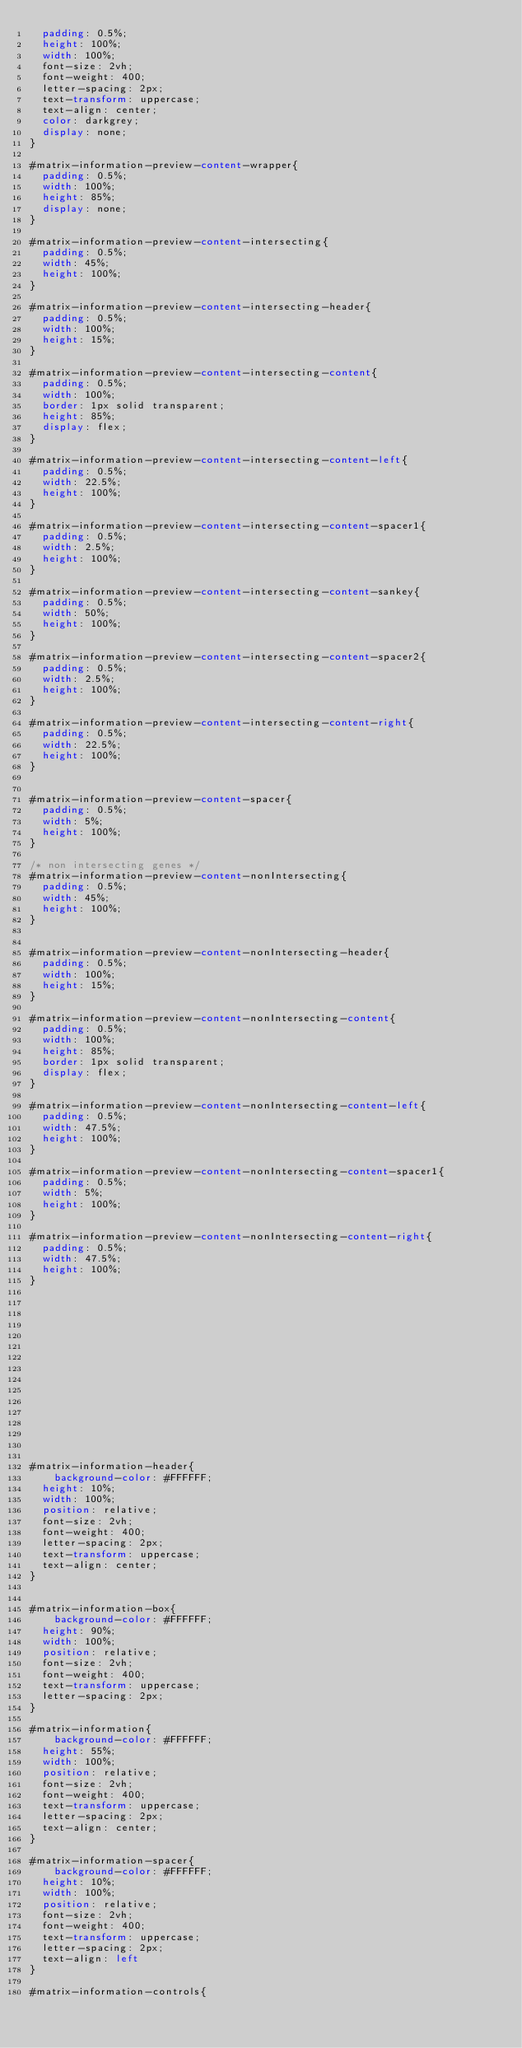<code> <loc_0><loc_0><loc_500><loc_500><_CSS_>	padding: 0.5%;
	height: 100%;
	width: 100%;
	font-size: 2vh;
	font-weight: 400;
	letter-spacing: 2px;
	text-transform: uppercase;
	text-align: center;
	color: darkgrey;
	display: none;
}

#matrix-information-preview-content-wrapper{
	padding: 0.5%;
	width: 100%;
	height: 85%;
	display: none;
}

#matrix-information-preview-content-intersecting{
	padding: 0.5%;
	width: 45%;
	height: 100%;
}

#matrix-information-preview-content-intersecting-header{
	padding: 0.5%;
	width: 100%;
	height: 15%;
}

#matrix-information-preview-content-intersecting-content{
	padding: 0.5%;
	width: 100%;
	border: 1px solid transparent;
	height: 85%;
	display: flex;
}

#matrix-information-preview-content-intersecting-content-left{
	padding: 0.5%;
	width: 22.5%;
	height: 100%;
}

#matrix-information-preview-content-intersecting-content-spacer1{
	padding: 0.5%;
	width: 2.5%;
	height: 100%;
}

#matrix-information-preview-content-intersecting-content-sankey{
	padding: 0.5%;
	width: 50%;
	height: 100%;
}

#matrix-information-preview-content-intersecting-content-spacer2{
	padding: 0.5%;
	width: 2.5%;
	height: 100%;
}

#matrix-information-preview-content-intersecting-content-right{
	padding: 0.5%;
	width: 22.5%;
	height: 100%;
}


#matrix-information-preview-content-spacer{
	padding: 0.5%;
	width: 5%;
	height: 100%;
}

/* non intersecting genes */
#matrix-information-preview-content-nonIntersecting{
	padding: 0.5%;
	width: 45%;
	height: 100%;
}


#matrix-information-preview-content-nonIntersecting-header{
	padding: 0.5%;
	width: 100%;
	height: 15%;
}

#matrix-information-preview-content-nonIntersecting-content{
	padding: 0.5%;
	width: 100%;
	height: 85%;
	border: 1px solid transparent;
	display: flex;
}

#matrix-information-preview-content-nonIntersecting-content-left{
	padding: 0.5%;
	width: 47.5%;
	height: 100%;
}

#matrix-information-preview-content-nonIntersecting-content-spacer1{
	padding: 0.5%;
	width: 5%;
	height: 100%;
}

#matrix-information-preview-content-nonIntersecting-content-right{
	padding: 0.5%;
	width: 47.5%;
	height: 100%;
}
















#matrix-information-header{
    background-color: #FFFFFF;
	height: 10%;
	width: 100%;
	position: relative;
	font-size: 2vh;
	font-weight: 400;
	letter-spacing: 2px;
	text-transform: uppercase;
	text-align: center;
}


#matrix-information-box{
    background-color: #FFFFFF;
	height: 90%;
	width: 100%;
	position: relative;
	font-size: 2vh;
	font-weight: 400;
	text-transform: uppercase;
	letter-spacing: 2px;
}

#matrix-information{
    background-color: #FFFFFF;
	height: 55%;
	width: 100%;
	position: relative;
	font-size: 2vh;
	font-weight: 400;
	text-transform: uppercase;
	letter-spacing: 2px;
	text-align: center;
}

#matrix-information-spacer{
    background-color: #FFFFFF;
	height: 10%;
	width: 100%;
	position: relative;
	font-size: 2vh;
	font-weight: 400;
	text-transform: uppercase;
	letter-spacing: 2px;
	text-align: left
}

#matrix-information-controls{</code> 